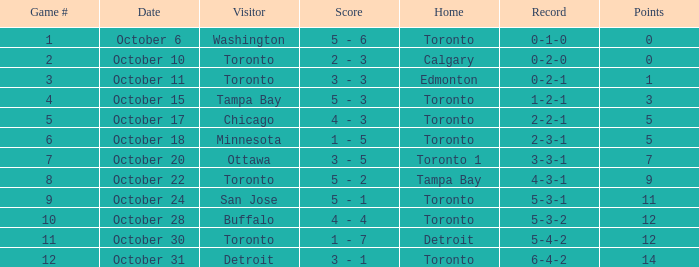What is the count when the record stood at 5-4-2? 1 - 7. 